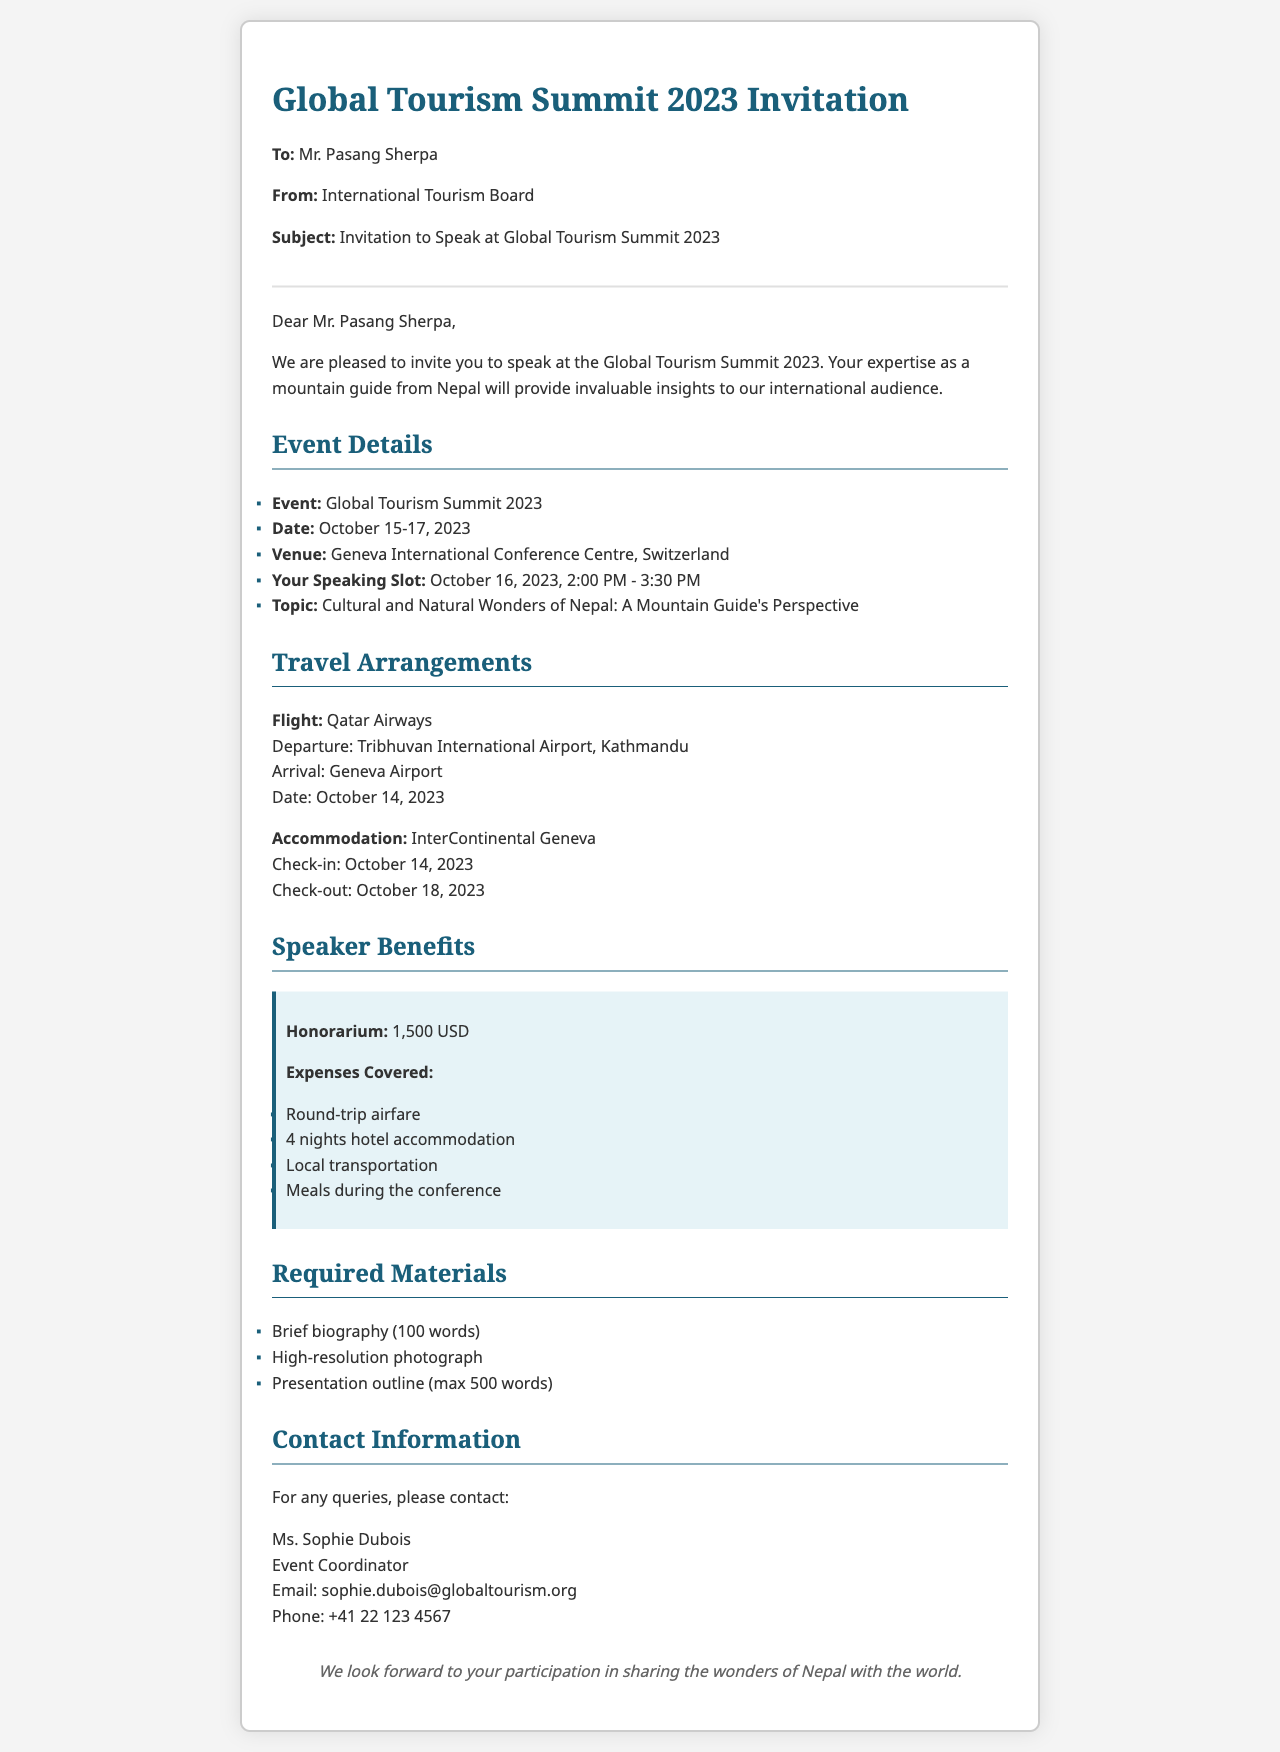What is the date of the conference? The date of the conference is stated as October 15-17, 2023.
Answer: October 15-17, 2023 What is the venue for the summit? The venue for the summit is mentioned in the event details section as Geneva International Conference Centre, Switzerland.
Answer: Geneva International Conference Centre, Switzerland When is Mr. Pasang Sherpa's speaking slot? Mr. Pasang Sherpa's speaking slot is indicated as October 16, 2023, 2:00 PM - 3:30 PM.
Answer: October 16, 2023, 2:00 PM - 3:30 PM What are the covered expenses for speakers? The covered expenses for speakers include round-trip airfare, 4 nights hotel accommodation, local transportation, and meals during the conference.
Answer: Round-trip airfare, 4 nights hotel accommodation, local transportation, meals Who should be contacted for queries? The contact for queries is Ms. Sophie Dubois, the Event Coordinator.
Answer: Ms. Sophie Dubois What is the honorarium for speaking? The honorarium for speaking is listed as 1,500 USD.
Answer: 1,500 USD What document is required for the speaker's biography? The document required for the speaker's biography is described as a brief biography of 100 words.
Answer: Brief biography (100 words) Which airline will Mr. Pasang Sherpa use to fly? The airline mentioned for the flight is Qatar Airways.
Answer: Qatar Airways What is the check-in date for the hotel? The check-in date for the hotel is given as October 14, 2023.
Answer: October 14, 2023 